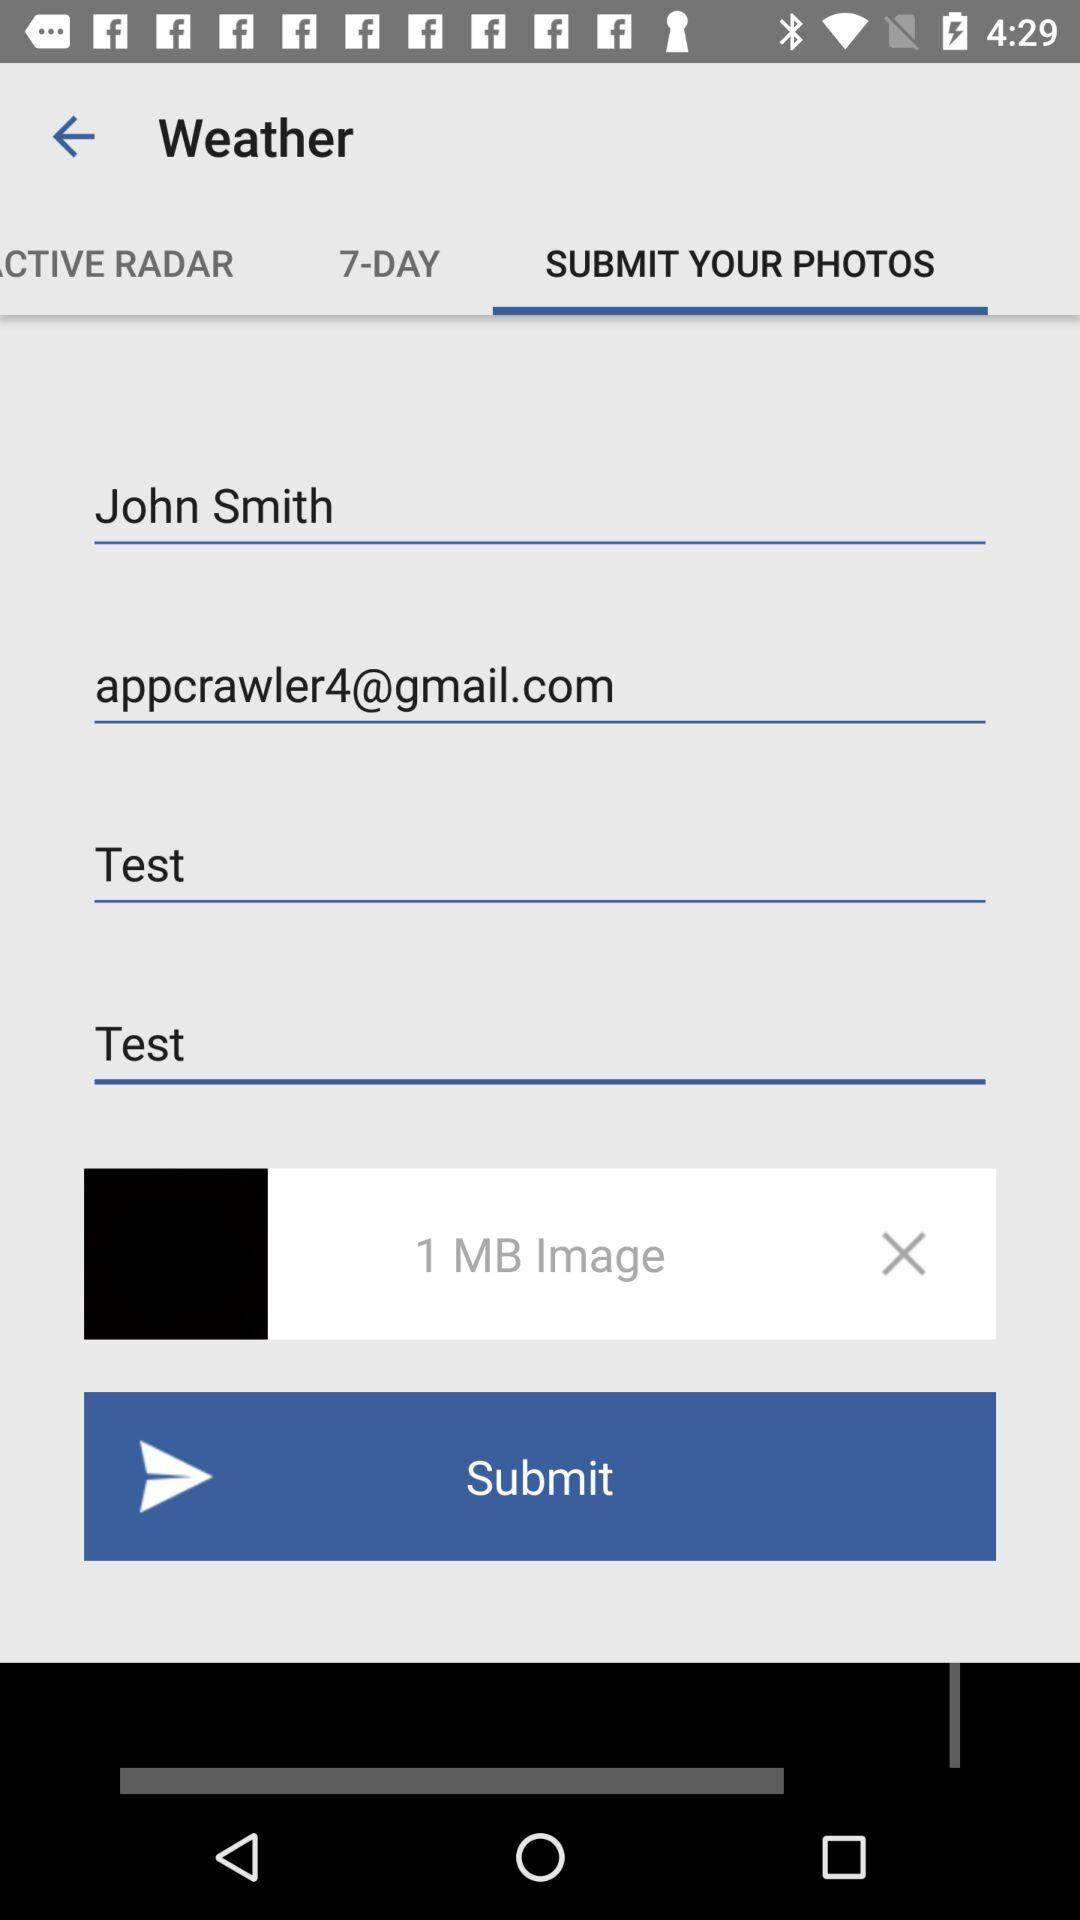What is the size of the attached image? The size is 1 MB. 